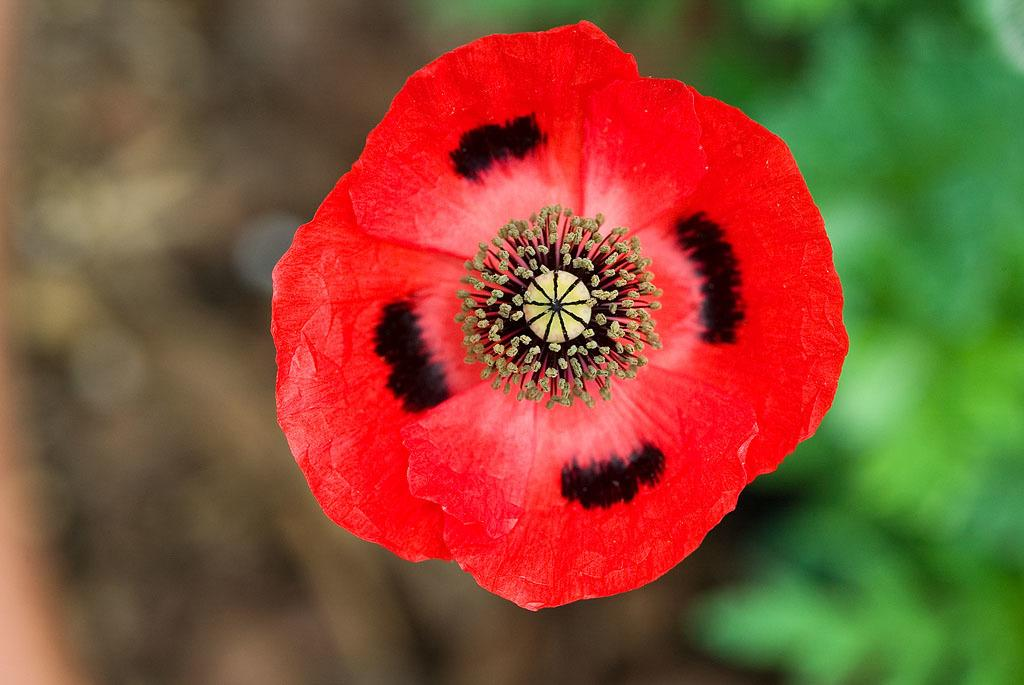What is the main subject of the image? There is a flower in the image. Can you describe the colors of the flower? The flower has red and black colors. How would you describe the background of the image? The background of the image is blurred. What type of advertisement is displayed on the boats in the image? There are no boats or advertisements present in the image; it features a flower with red and black colors against a blurred background. 